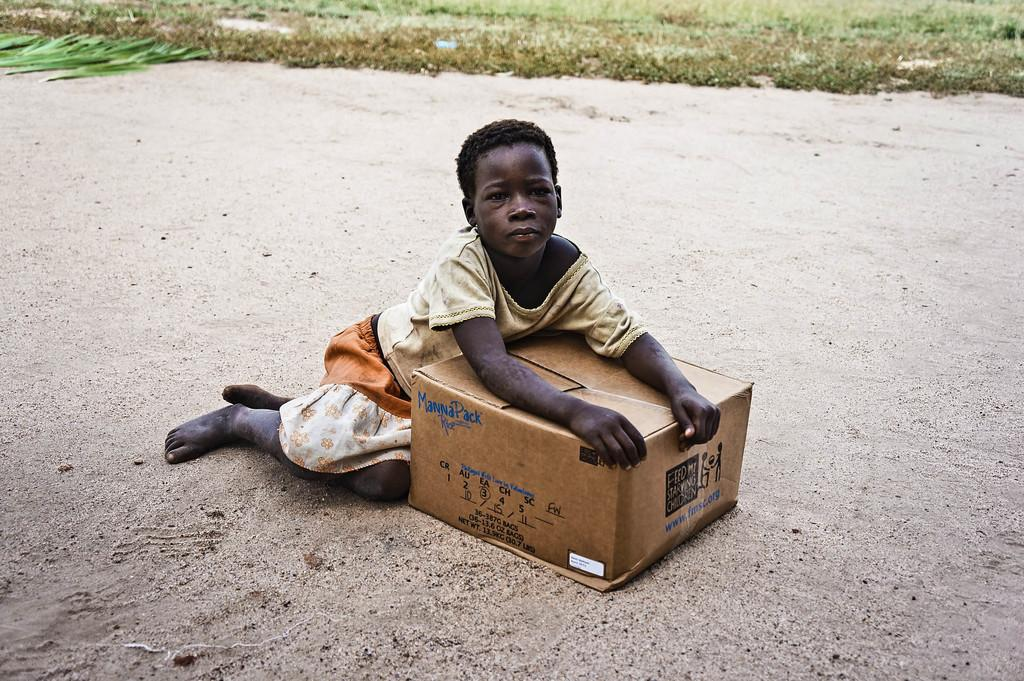What is the girl in the image doing? A: The girl is sitting in the image. What is the girl holding in the image? The girl is holding a cardboard box. What can be seen in the background of the image? There is grass visible in the background of the image. What is present at the bottom of the image? There is sand visible at the bottom of the image. What is written or depicted on the cardboard box? There is text on the cardboard box. Can you hear the pear sneezing in the image? There is no pear present in the image, and therefore it cannot sneeze. 